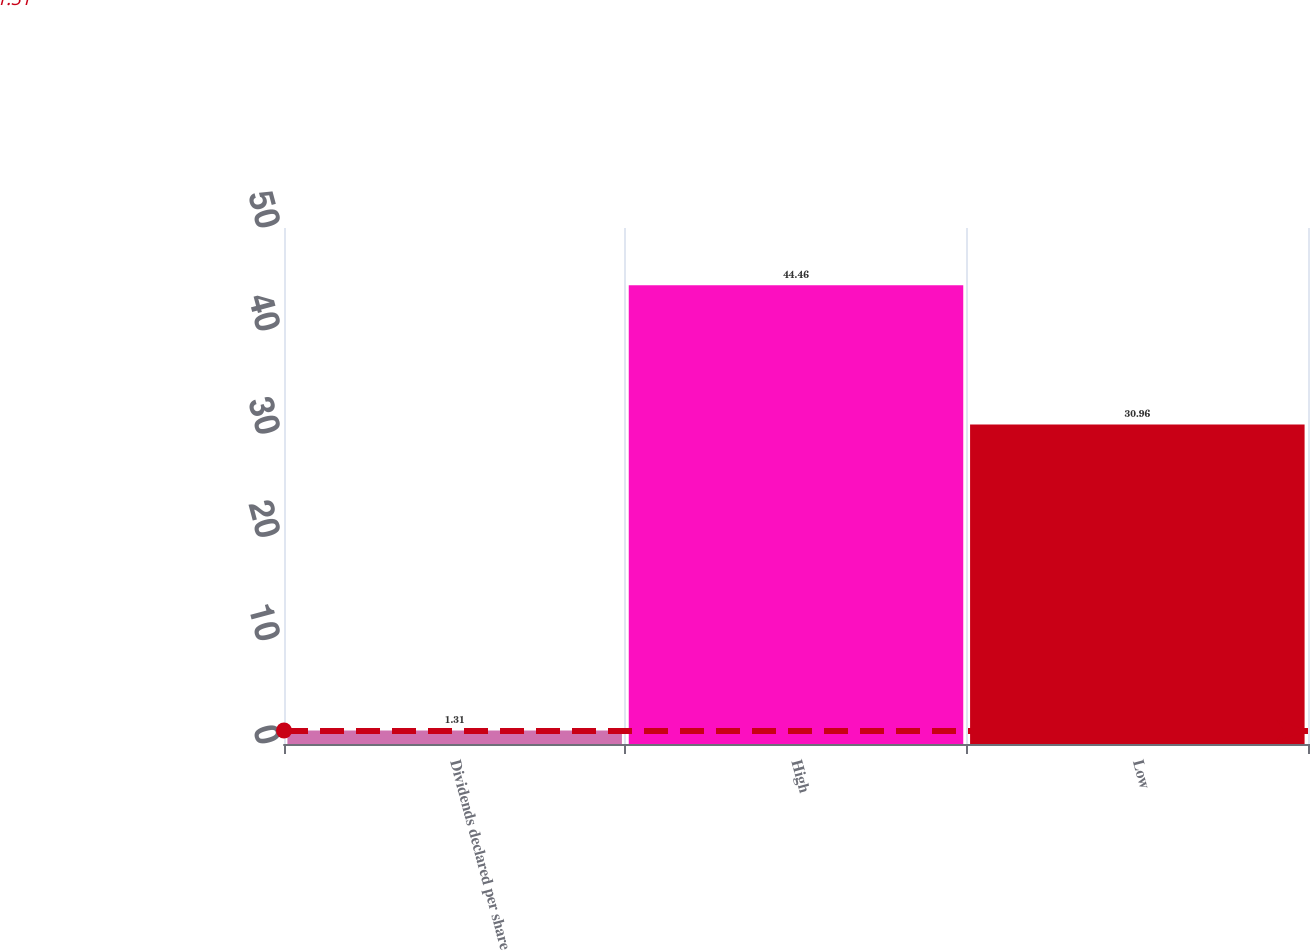<chart> <loc_0><loc_0><loc_500><loc_500><bar_chart><fcel>Dividends declared per share<fcel>High<fcel>Low<nl><fcel>1.31<fcel>44.46<fcel>30.96<nl></chart> 